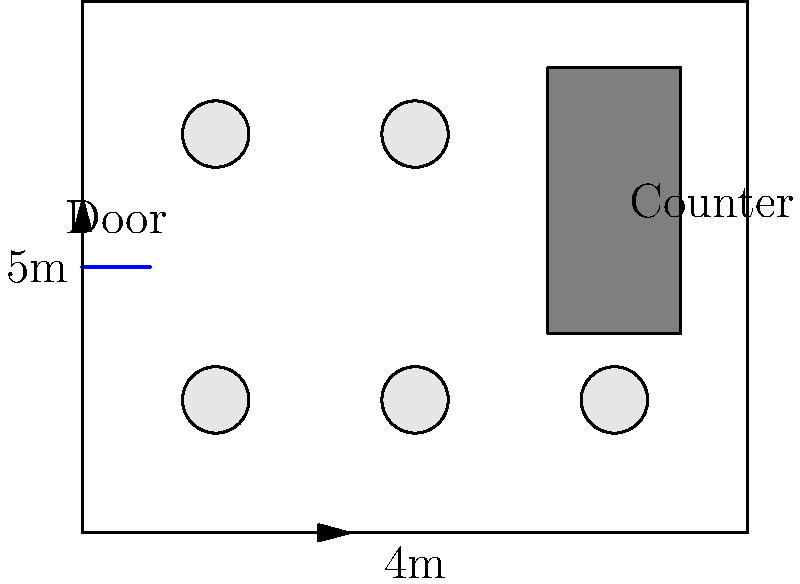Given the floor plan of your café (4m x 5m) with a fixed counter and door position, you currently have 6 circular tables with a radius of 0.5m each. To optimize seating, you're considering replacing them with rectangular tables. If each person requires a minimum of 0.6m of table edge space, and you want to maintain at least 1m of space between tables and walls for movement, what is the maximum number of customers you can seat using rectangular tables? Let's approach this step-by-step:

1. Calculate the usable floor space:
   - Total floor space: $4\text{m} \times 5\text{m} = 20\text{m}^2$
   - Counter space (approximate): $2\text{m} \times 2\text{m} = 4\text{m}^2$
   - Usable space: $20\text{m}^2 - 4\text{m}^2 = 16\text{m}^2$

2. Account for movement space:
   - We need 1m space around the perimeter
   - Usable width: $4\text{m} - 2\text{m} = 2\text{m}$
   - Usable length: $5\text{m} - 2\text{m} = 3\text{m}$
   - Actual usable area: $2\text{m} \times 3\text{m} = 6\text{m}^2$

3. Determine optimal table arrangement:
   - We can fit 2 tables in the width (2m) and 3 tables in the length (3m)
   - Table size: $1\text{m} \times 1\text{m}$ (approx.)

4. Calculate seating capacity:
   - Each 1m table edge can seat: $1\text{m} \div 0.6\text{m} = 1.67$ (round down to 1 person)
   - Each table can seat 4 people (one on each side)
   - Total tables: $2 \times 3 = 6$ tables
   - Total seating capacity: $6 \text{ tables} \times 4 \text{ people} = 24 \text{ people}$
Answer: 24 customers 